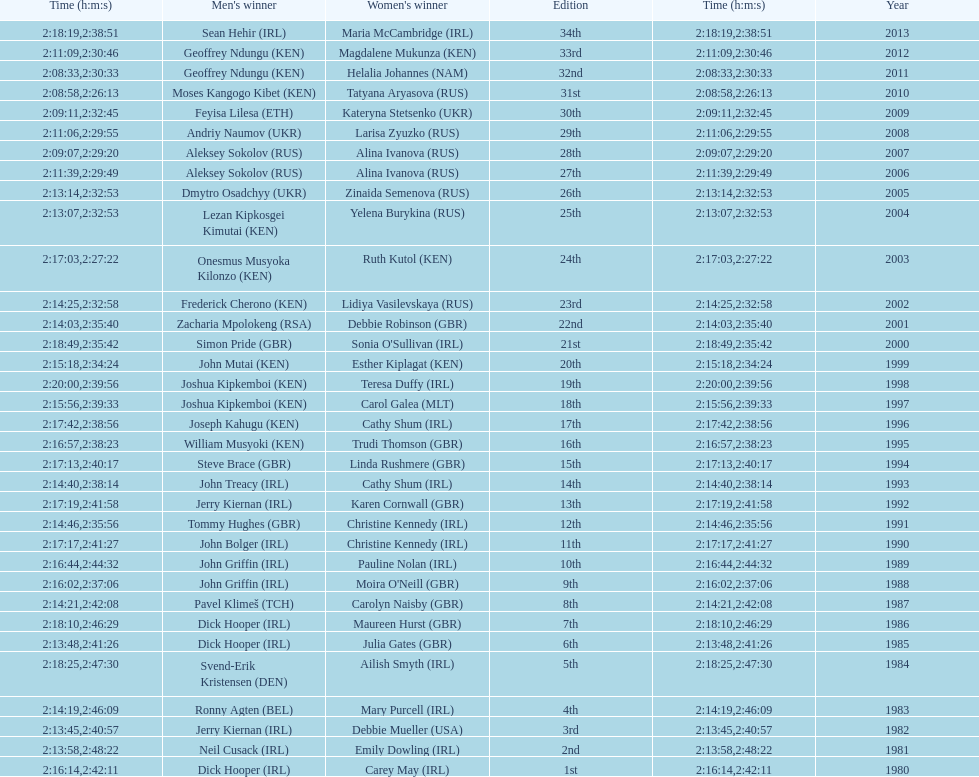Help me parse the entirety of this table. {'header': ['Time (h:m:s)', "Men's winner", "Women's winner", 'Edition', 'Time (h:m:s)', 'Year'], 'rows': [['2:18:19', 'Sean Hehir\xa0(IRL)', 'Maria McCambridge\xa0(IRL)', '34th', '2:38:51', '2013'], ['2:11:09', 'Geoffrey Ndungu\xa0(KEN)', 'Magdalene Mukunza\xa0(KEN)', '33rd', '2:30:46', '2012'], ['2:08:33', 'Geoffrey Ndungu\xa0(KEN)', 'Helalia Johannes\xa0(NAM)', '32nd', '2:30:33', '2011'], ['2:08:58', 'Moses Kangogo Kibet\xa0(KEN)', 'Tatyana Aryasova\xa0(RUS)', '31st', '2:26:13', '2010'], ['2:09:11', 'Feyisa Lilesa\xa0(ETH)', 'Kateryna Stetsenko\xa0(UKR)', '30th', '2:32:45', '2009'], ['2:11:06', 'Andriy Naumov\xa0(UKR)', 'Larisa Zyuzko\xa0(RUS)', '29th', '2:29:55', '2008'], ['2:09:07', 'Aleksey Sokolov\xa0(RUS)', 'Alina Ivanova\xa0(RUS)', '28th', '2:29:20', '2007'], ['2:11:39', 'Aleksey Sokolov\xa0(RUS)', 'Alina Ivanova\xa0(RUS)', '27th', '2:29:49', '2006'], ['2:13:14', 'Dmytro Osadchyy\xa0(UKR)', 'Zinaida Semenova\xa0(RUS)', '26th', '2:32:53', '2005'], ['2:13:07', 'Lezan Kipkosgei Kimutai\xa0(KEN)', 'Yelena Burykina\xa0(RUS)', '25th', '2:32:53', '2004'], ['2:17:03', 'Onesmus Musyoka Kilonzo\xa0(KEN)', 'Ruth Kutol\xa0(KEN)', '24th', '2:27:22', '2003'], ['2:14:25', 'Frederick Cherono\xa0(KEN)', 'Lidiya Vasilevskaya\xa0(RUS)', '23rd', '2:32:58', '2002'], ['2:14:03', 'Zacharia Mpolokeng\xa0(RSA)', 'Debbie Robinson\xa0(GBR)', '22nd', '2:35:40', '2001'], ['2:18:49', 'Simon Pride\xa0(GBR)', "Sonia O'Sullivan\xa0(IRL)", '21st', '2:35:42', '2000'], ['2:15:18', 'John Mutai\xa0(KEN)', 'Esther Kiplagat\xa0(KEN)', '20th', '2:34:24', '1999'], ['2:20:00', 'Joshua Kipkemboi\xa0(KEN)', 'Teresa Duffy\xa0(IRL)', '19th', '2:39:56', '1998'], ['2:15:56', 'Joshua Kipkemboi\xa0(KEN)', 'Carol Galea\xa0(MLT)', '18th', '2:39:33', '1997'], ['2:17:42', 'Joseph Kahugu\xa0(KEN)', 'Cathy Shum\xa0(IRL)', '17th', '2:38:56', '1996'], ['2:16:57', 'William Musyoki\xa0(KEN)', 'Trudi Thomson\xa0(GBR)', '16th', '2:38:23', '1995'], ['2:17:13', 'Steve Brace\xa0(GBR)', 'Linda Rushmere\xa0(GBR)', '15th', '2:40:17', '1994'], ['2:14:40', 'John Treacy\xa0(IRL)', 'Cathy Shum\xa0(IRL)', '14th', '2:38:14', '1993'], ['2:17:19', 'Jerry Kiernan\xa0(IRL)', 'Karen Cornwall\xa0(GBR)', '13th', '2:41:58', '1992'], ['2:14:46', 'Tommy Hughes\xa0(GBR)', 'Christine Kennedy\xa0(IRL)', '12th', '2:35:56', '1991'], ['2:17:17', 'John Bolger\xa0(IRL)', 'Christine Kennedy\xa0(IRL)', '11th', '2:41:27', '1990'], ['2:16:44', 'John Griffin\xa0(IRL)', 'Pauline Nolan\xa0(IRL)', '10th', '2:44:32', '1989'], ['2:16:02', 'John Griffin\xa0(IRL)', "Moira O'Neill\xa0(GBR)", '9th', '2:37:06', '1988'], ['2:14:21', 'Pavel Klimeš\xa0(TCH)', 'Carolyn Naisby\xa0(GBR)', '8th', '2:42:08', '1987'], ['2:18:10', 'Dick Hooper\xa0(IRL)', 'Maureen Hurst\xa0(GBR)', '7th', '2:46:29', '1986'], ['2:13:48', 'Dick Hooper\xa0(IRL)', 'Julia Gates\xa0(GBR)', '6th', '2:41:26', '1985'], ['2:18:25', 'Svend-Erik Kristensen\xa0(DEN)', 'Ailish Smyth\xa0(IRL)', '5th', '2:47:30', '1984'], ['2:14:19', 'Ronny Agten\xa0(BEL)', 'Mary Purcell\xa0(IRL)', '4th', '2:46:09', '1983'], ['2:13:45', 'Jerry Kiernan\xa0(IRL)', 'Debbie Mueller\xa0(USA)', '3rd', '2:40:57', '1982'], ['2:13:58', 'Neil Cusack\xa0(IRL)', 'Emily Dowling\xa0(IRL)', '2nd', '2:48:22', '1981'], ['2:16:14', 'Dick Hooper\xa0(IRL)', 'Carey May\xa0(IRL)', '1st', '2:42:11', '1980']]} Which country is represented for both men and women at the top of the list? Ireland. 